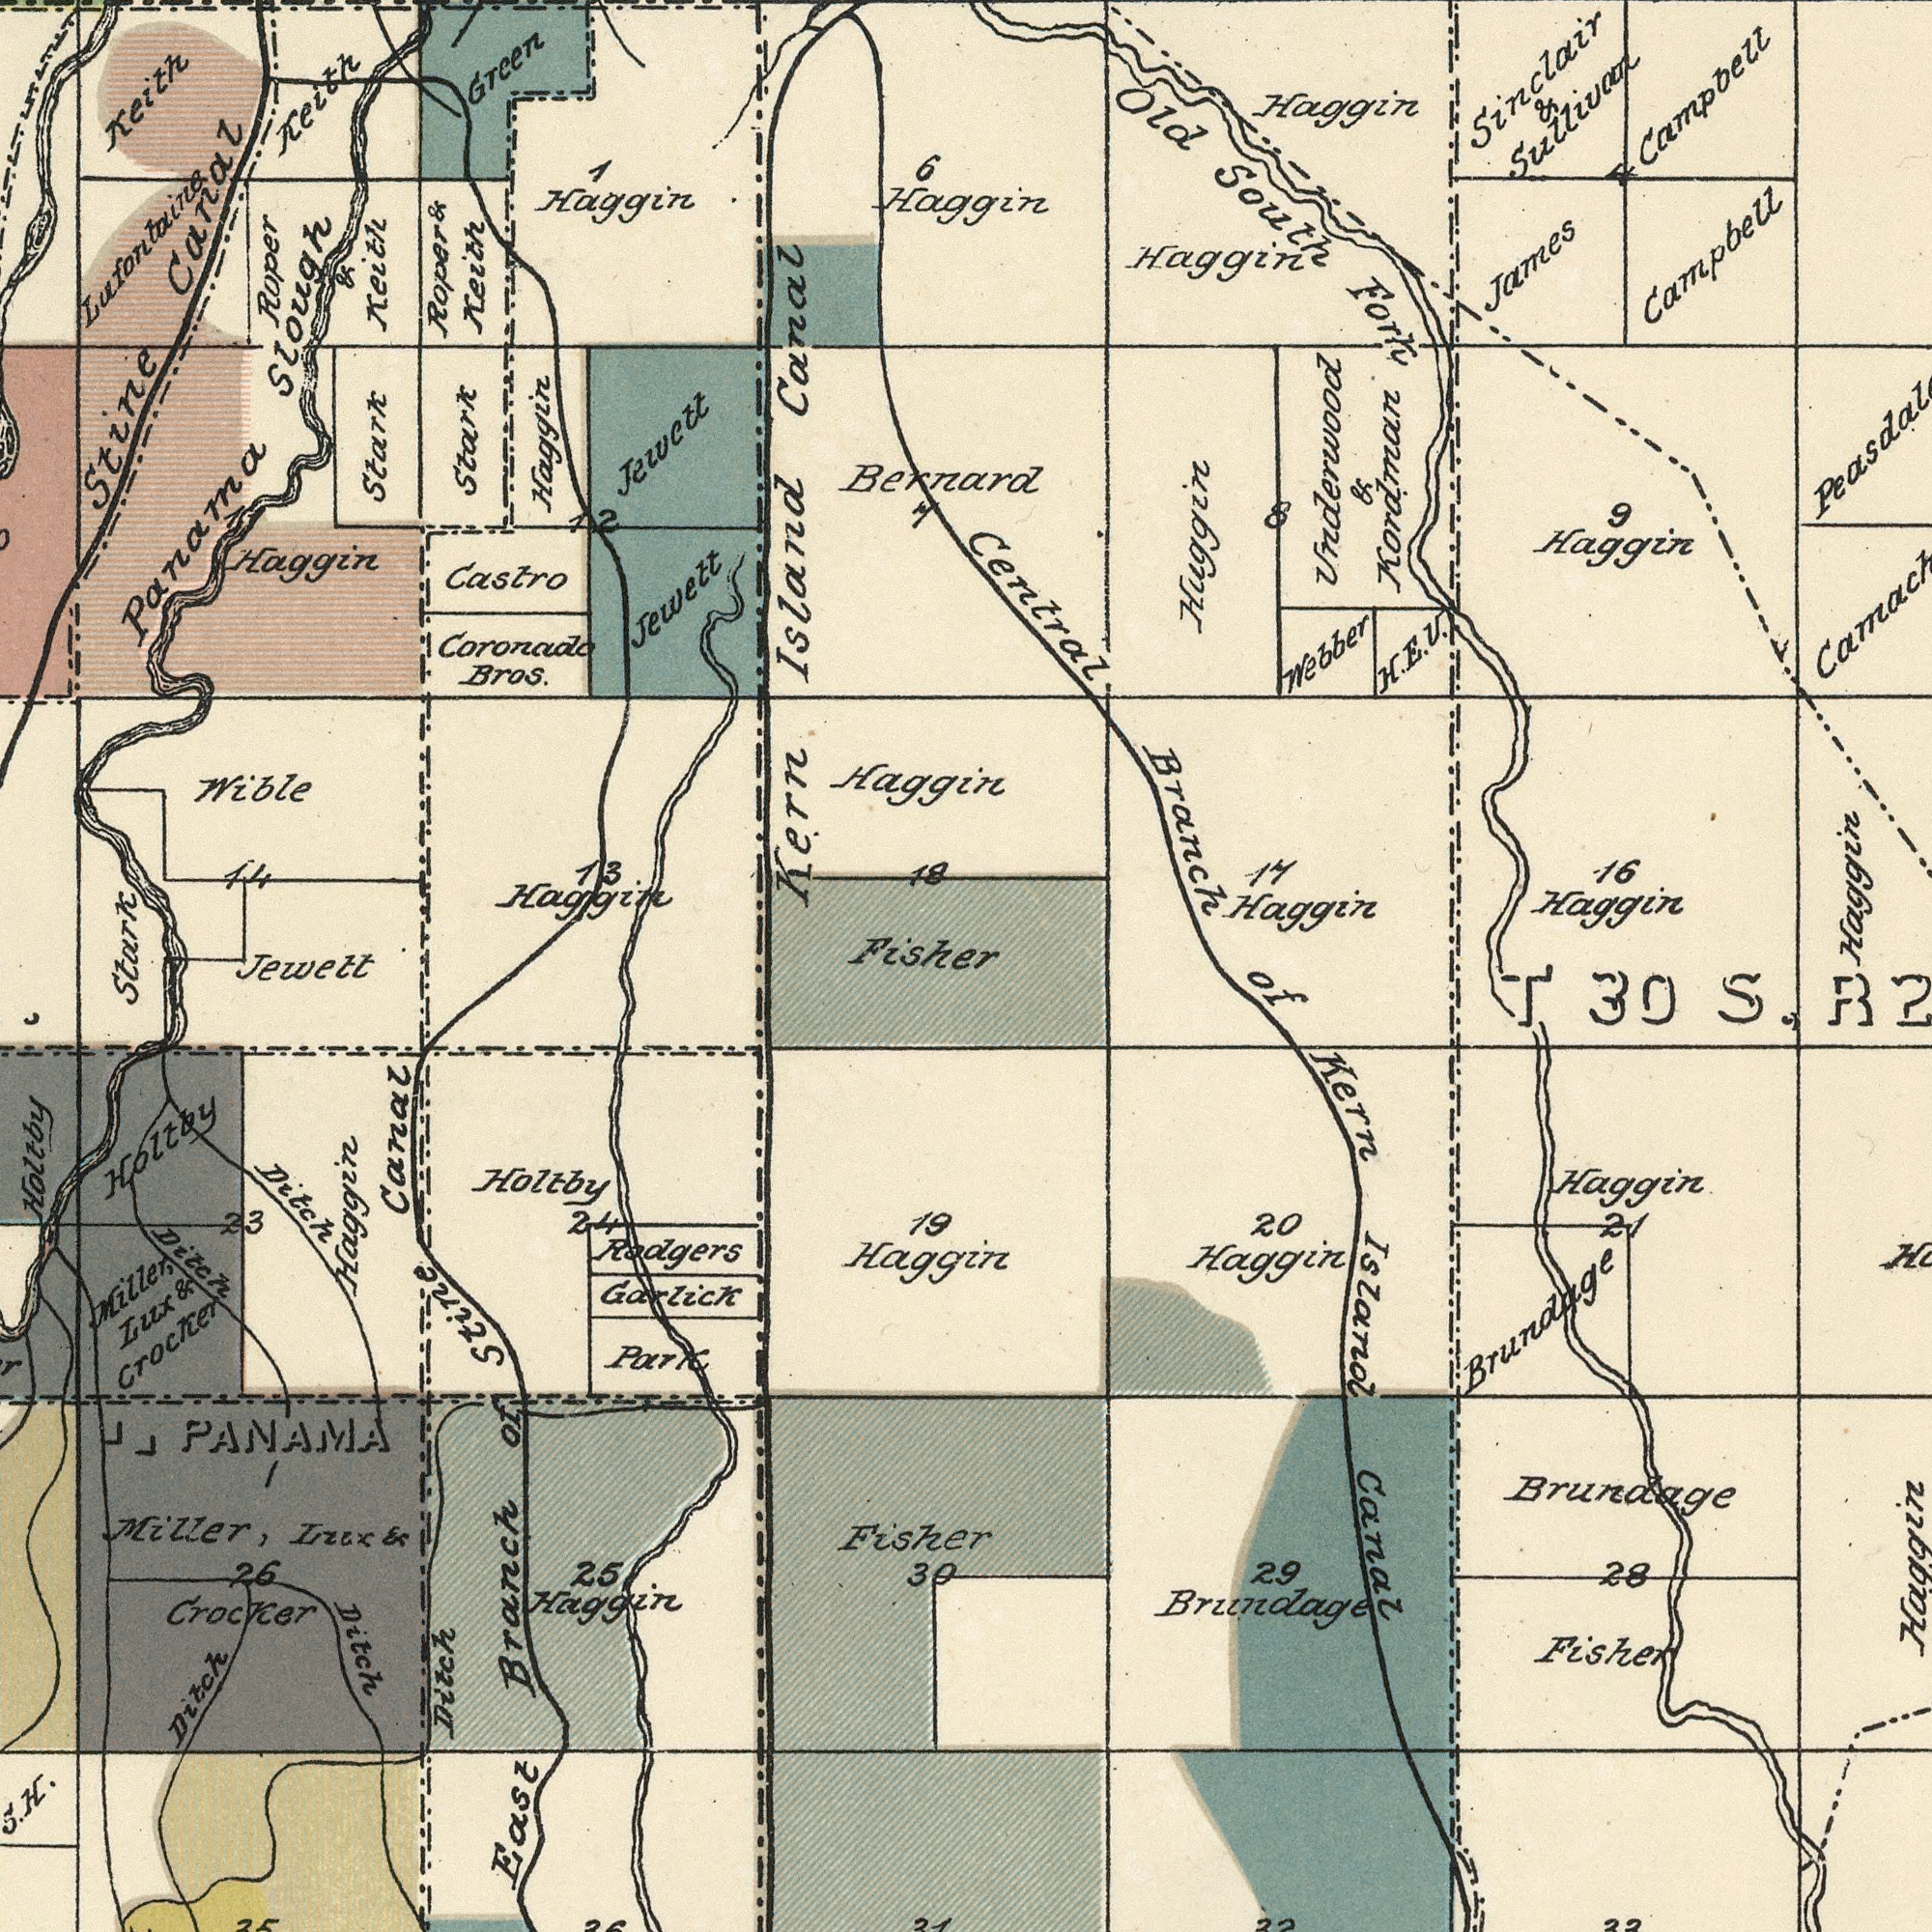What text appears in the bottom-right area of the image? of Kern Island Canal Brundage Brundage Haggin Brundage Fisher 20 29 Haggin 28 Haggin T 30 S. R 21 What text is visible in the upper-right corner? Central Branch Campbell Underwood & Kordman Old South Fork Haggin 16 Haggin H. Webber E. V. Haggin Campbell Haggin Haggin 9 Haggin James Sinclair & Sullivan Huggin 8 14 What text appears in the bottom-left area of the image? Fisher East Branch of Stine Canal Ditch Holtby Haggin Rodgers Miller, Lux & Crocker Holtby Holtby PANAMA Fisher Miller, Lux & Crocker Ditch 19 Park Ditch Haggin Haggin 26 Ditch 23 30 25 Garlick Ditch 24 Jewett Stark H. What text can you see in the top-left section? Kern Island Canal Wible Panama Slough Coronado Bros. Roper & Keith Haggin Castro Roper & Keith Jewett Haggin Stark Jewett Keith Haggin Green Keith Haggin Stark Bernard Stine Canal 6 18 1 14 Haggin Lufontaine 12 Haggin 7 13 